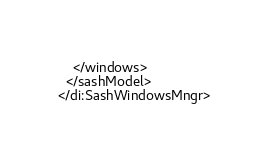<code> <loc_0><loc_0><loc_500><loc_500><_D_>    </windows>
  </sashModel>
</di:SashWindowsMngr>
</code> 